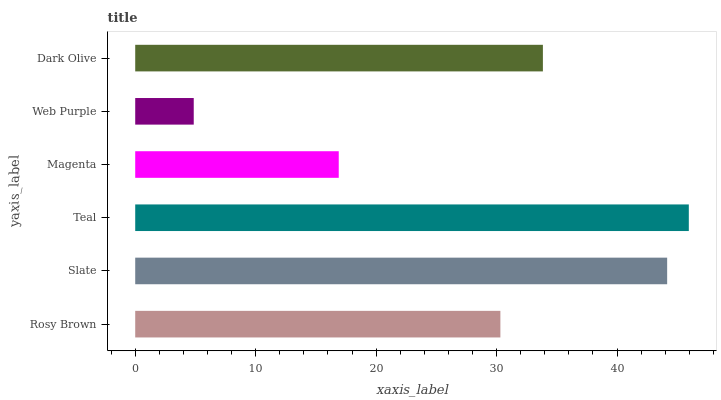Is Web Purple the minimum?
Answer yes or no. Yes. Is Teal the maximum?
Answer yes or no. Yes. Is Slate the minimum?
Answer yes or no. No. Is Slate the maximum?
Answer yes or no. No. Is Slate greater than Rosy Brown?
Answer yes or no. Yes. Is Rosy Brown less than Slate?
Answer yes or no. Yes. Is Rosy Brown greater than Slate?
Answer yes or no. No. Is Slate less than Rosy Brown?
Answer yes or no. No. Is Dark Olive the high median?
Answer yes or no. Yes. Is Rosy Brown the low median?
Answer yes or no. Yes. Is Web Purple the high median?
Answer yes or no. No. Is Web Purple the low median?
Answer yes or no. No. 